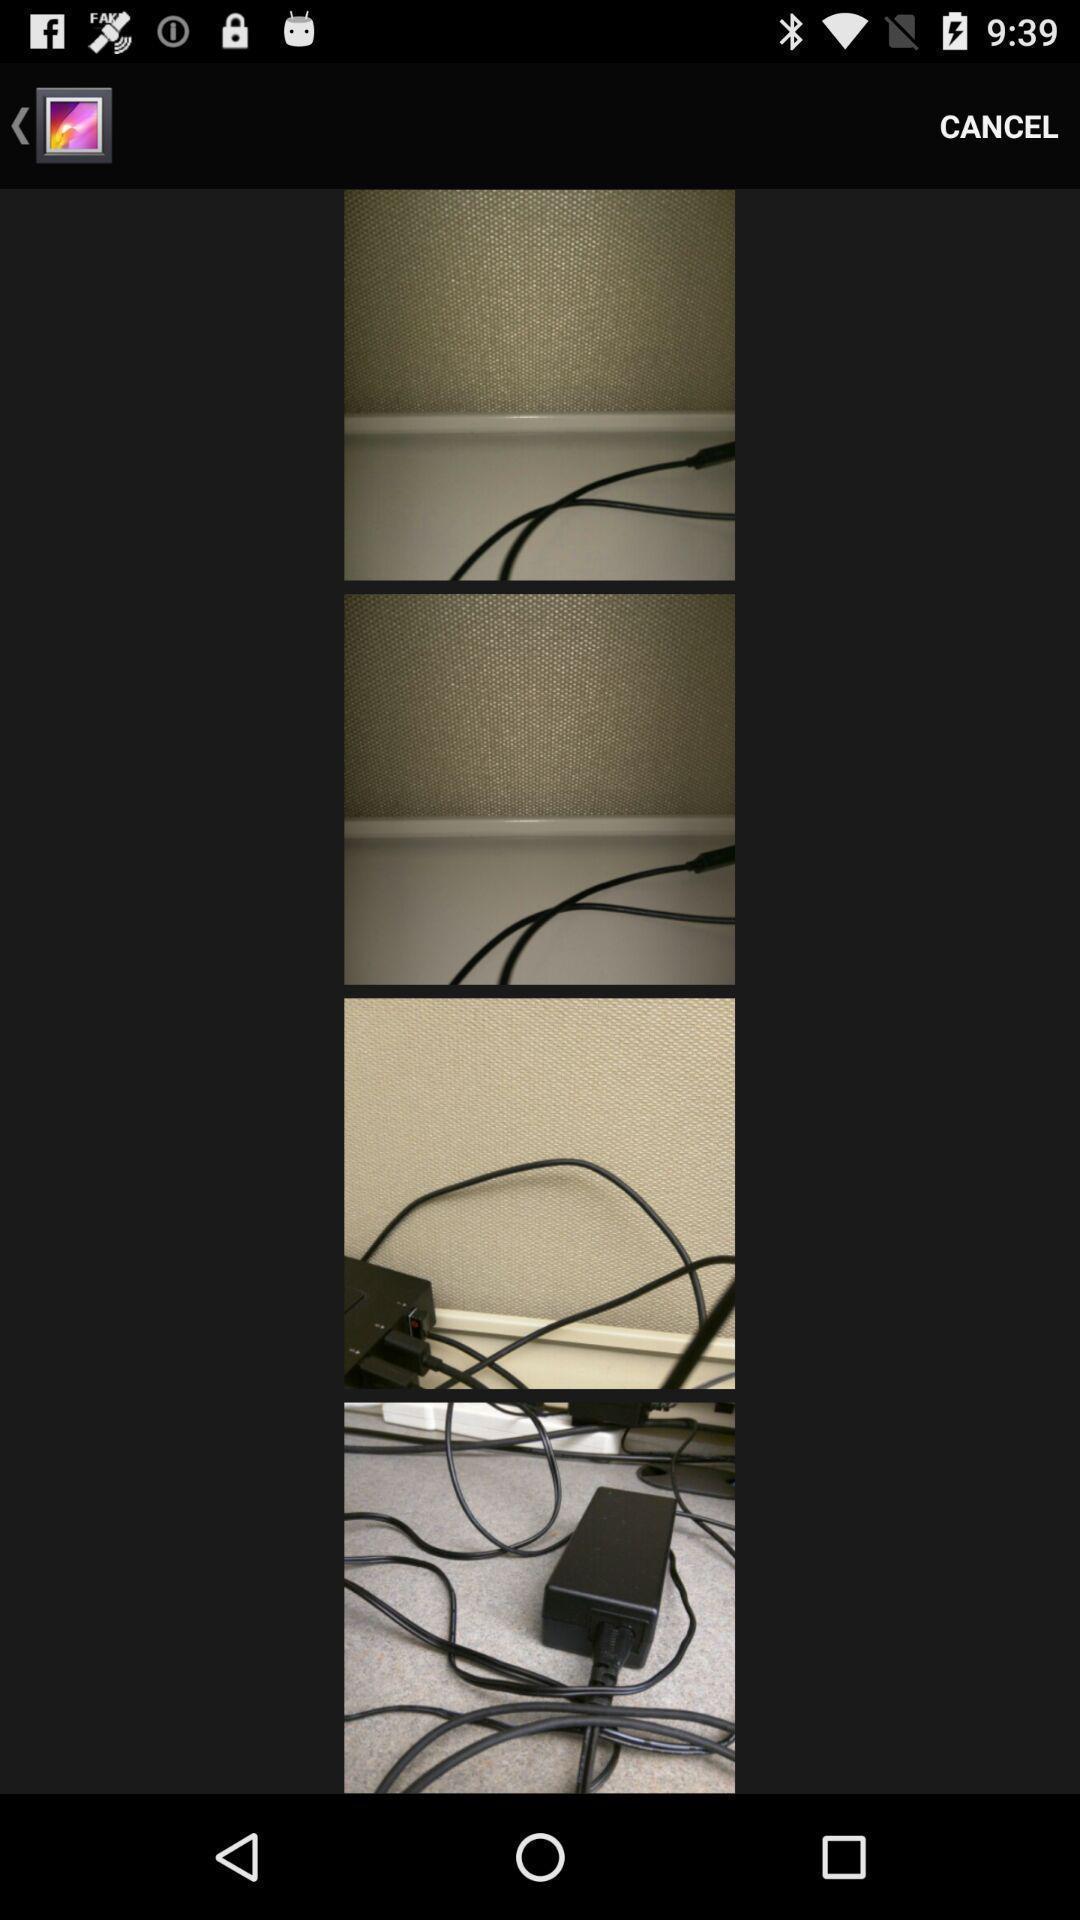Provide a detailed account of this screenshot. Page showing list of images. 